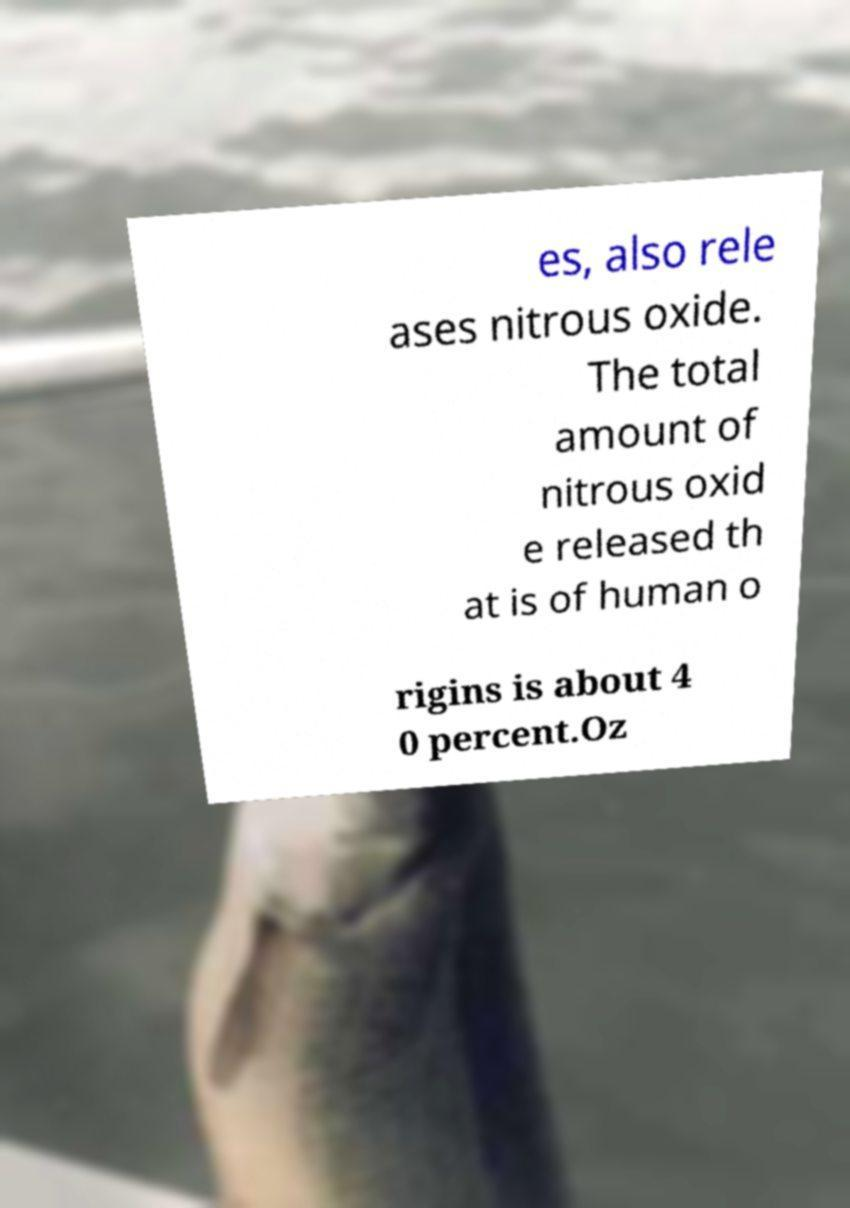Please read and relay the text visible in this image. What does it say? es, also rele ases nitrous oxide. The total amount of nitrous oxid e released th at is of human o rigins is about 4 0 percent.Oz 